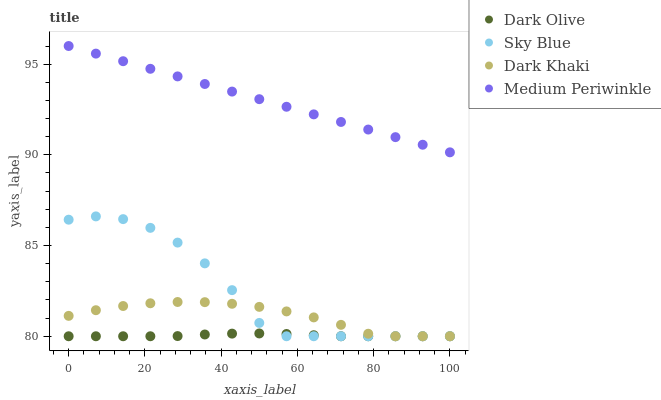Does Dark Olive have the minimum area under the curve?
Answer yes or no. Yes. Does Medium Periwinkle have the maximum area under the curve?
Answer yes or no. Yes. Does Sky Blue have the minimum area under the curve?
Answer yes or no. No. Does Sky Blue have the maximum area under the curve?
Answer yes or no. No. Is Medium Periwinkle the smoothest?
Answer yes or no. Yes. Is Sky Blue the roughest?
Answer yes or no. Yes. Is Dark Olive the smoothest?
Answer yes or no. No. Is Dark Olive the roughest?
Answer yes or no. No. Does Dark Khaki have the lowest value?
Answer yes or no. Yes. Does Medium Periwinkle have the lowest value?
Answer yes or no. No. Does Medium Periwinkle have the highest value?
Answer yes or no. Yes. Does Sky Blue have the highest value?
Answer yes or no. No. Is Dark Olive less than Medium Periwinkle?
Answer yes or no. Yes. Is Medium Periwinkle greater than Sky Blue?
Answer yes or no. Yes. Does Dark Khaki intersect Sky Blue?
Answer yes or no. Yes. Is Dark Khaki less than Sky Blue?
Answer yes or no. No. Is Dark Khaki greater than Sky Blue?
Answer yes or no. No. Does Dark Olive intersect Medium Periwinkle?
Answer yes or no. No. 